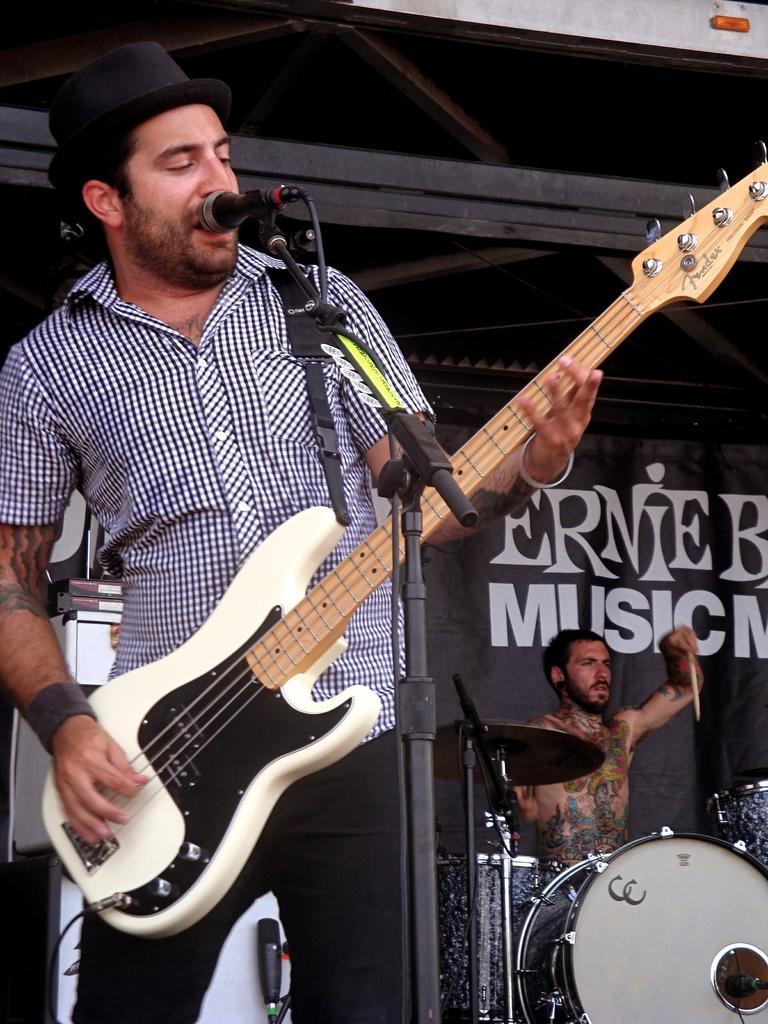In one or two sentences, can you explain what this image depicts? In this picture there is a man Who has black hat and holding a guitar and singing through a mic. There are musical instruments in the background. A shirtless guy with a tattoo on him is in the background. ARMENIAN MUSIC is written on a poster in the background. 